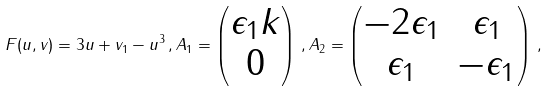Convert formula to latex. <formula><loc_0><loc_0><loc_500><loc_500>F ( u , v ) = 3 u + v _ { 1 } - u ^ { 3 } \, , A _ { 1 } = \begin{pmatrix} \epsilon _ { 1 } k \\ 0 \end{pmatrix} \, , A _ { 2 } = \begin{pmatrix} - 2 \epsilon _ { 1 } & \epsilon _ { 1 } \\ \epsilon _ { 1 } & - \epsilon _ { 1 } \end{pmatrix} \, ,</formula> 